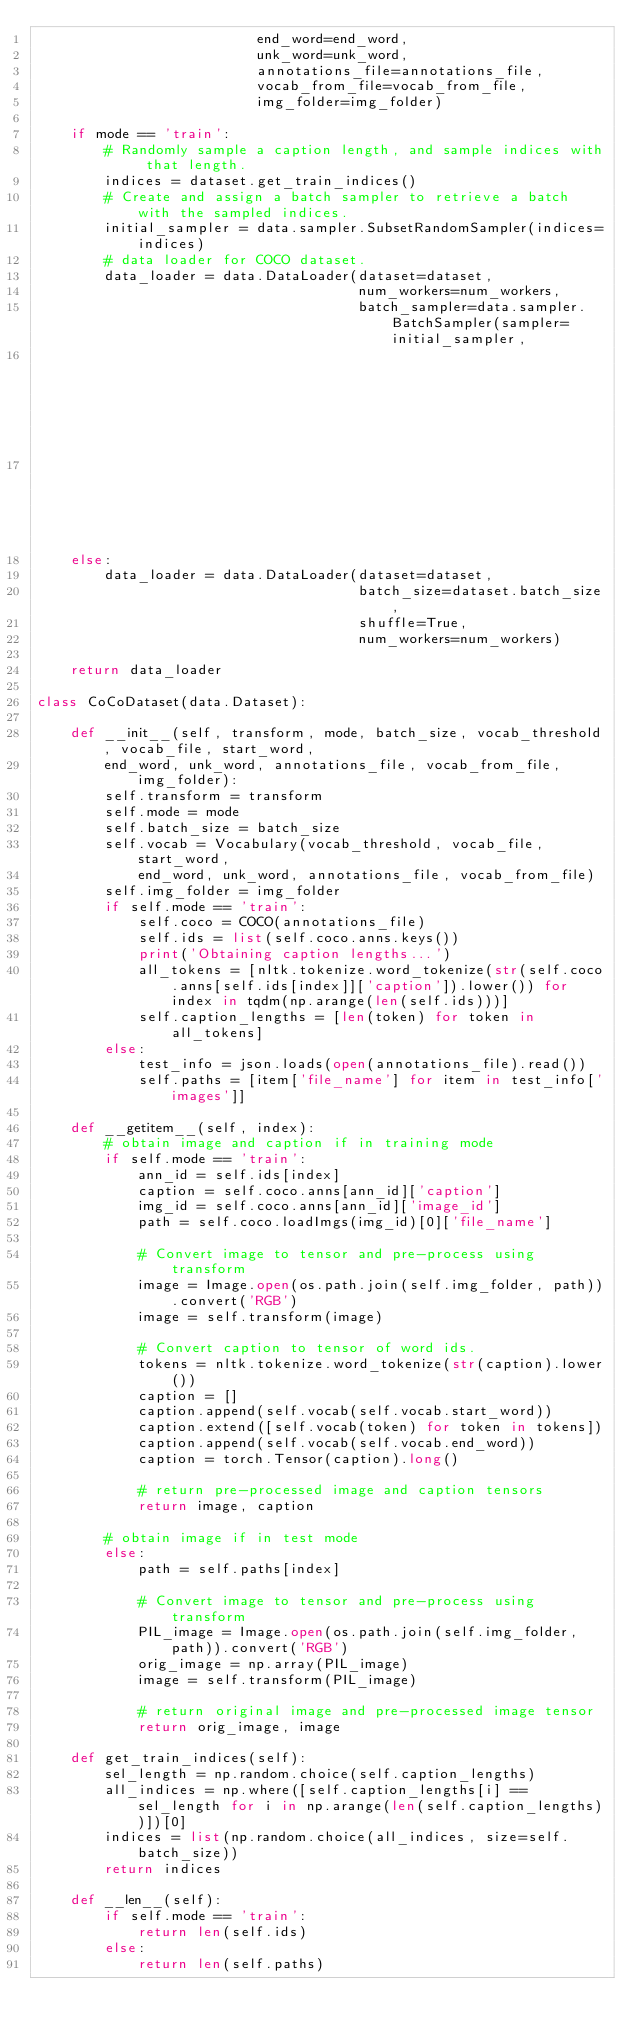Convert code to text. <code><loc_0><loc_0><loc_500><loc_500><_Python_>                          end_word=end_word,
                          unk_word=unk_word,
                          annotations_file=annotations_file,
                          vocab_from_file=vocab_from_file,
                          img_folder=img_folder)

    if mode == 'train':
        # Randomly sample a caption length, and sample indices with that length.
        indices = dataset.get_train_indices()
        # Create and assign a batch sampler to retrieve a batch with the sampled indices.
        initial_sampler = data.sampler.SubsetRandomSampler(indices=indices)
        # data loader for COCO dataset.
        data_loader = data.DataLoader(dataset=dataset, 
                                      num_workers=num_workers,
                                      batch_sampler=data.sampler.BatchSampler(sampler=initial_sampler,
                                                                              batch_size=dataset.batch_size,
                                                                              drop_last=False))
    else:
        data_loader = data.DataLoader(dataset=dataset,
                                      batch_size=dataset.batch_size,
                                      shuffle=True,
                                      num_workers=num_workers)

    return data_loader

class CoCoDataset(data.Dataset):
    
    def __init__(self, transform, mode, batch_size, vocab_threshold, vocab_file, start_word, 
        end_word, unk_word, annotations_file, vocab_from_file, img_folder):
        self.transform = transform
        self.mode = mode
        self.batch_size = batch_size
        self.vocab = Vocabulary(vocab_threshold, vocab_file, start_word,
            end_word, unk_word, annotations_file, vocab_from_file)
        self.img_folder = img_folder
        if self.mode == 'train':
            self.coco = COCO(annotations_file)
            self.ids = list(self.coco.anns.keys())
            print('Obtaining caption lengths...')
            all_tokens = [nltk.tokenize.word_tokenize(str(self.coco.anns[self.ids[index]]['caption']).lower()) for index in tqdm(np.arange(len(self.ids)))]
            self.caption_lengths = [len(token) for token in all_tokens]
        else:
            test_info = json.loads(open(annotations_file).read())
            self.paths = [item['file_name'] for item in test_info['images']]
        
    def __getitem__(self, index):
        # obtain image and caption if in training mode
        if self.mode == 'train':
            ann_id = self.ids[index]
            caption = self.coco.anns[ann_id]['caption']
            img_id = self.coco.anns[ann_id]['image_id']
            path = self.coco.loadImgs(img_id)[0]['file_name']

            # Convert image to tensor and pre-process using transform
            image = Image.open(os.path.join(self.img_folder, path)).convert('RGB')
            image = self.transform(image)

            # Convert caption to tensor of word ids.
            tokens = nltk.tokenize.word_tokenize(str(caption).lower())
            caption = []
            caption.append(self.vocab(self.vocab.start_word))
            caption.extend([self.vocab(token) for token in tokens])
            caption.append(self.vocab(self.vocab.end_word))
            caption = torch.Tensor(caption).long()

            # return pre-processed image and caption tensors
            return image, caption

        # obtain image if in test mode
        else:
            path = self.paths[index]

            # Convert image to tensor and pre-process using transform
            PIL_image = Image.open(os.path.join(self.img_folder, path)).convert('RGB')
            orig_image = np.array(PIL_image)
            image = self.transform(PIL_image)

            # return original image and pre-processed image tensor
            return orig_image, image

    def get_train_indices(self):
        sel_length = np.random.choice(self.caption_lengths)
        all_indices = np.where([self.caption_lengths[i] == sel_length for i in np.arange(len(self.caption_lengths))])[0]
        indices = list(np.random.choice(all_indices, size=self.batch_size))
        return indices

    def __len__(self):
        if self.mode == 'train':
            return len(self.ids)
        else:
            return len(self.paths)</code> 